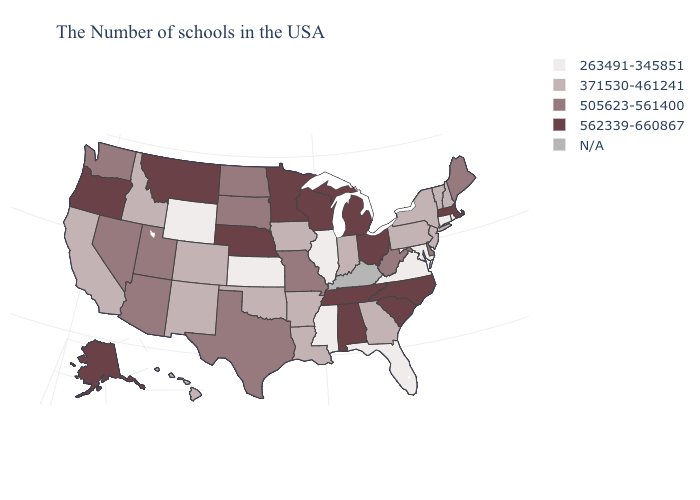Is the legend a continuous bar?
Write a very short answer. No. Among the states that border Delaware , which have the lowest value?
Write a very short answer. Maryland. What is the value of Oklahoma?
Concise answer only. 371530-461241. Name the states that have a value in the range 562339-660867?
Quick response, please. Massachusetts, North Carolina, South Carolina, Ohio, Michigan, Alabama, Tennessee, Wisconsin, Minnesota, Nebraska, Montana, Oregon, Alaska. What is the value of New York?
Keep it brief. 371530-461241. Does Nevada have the lowest value in the USA?
Keep it brief. No. Does Hawaii have the highest value in the West?
Quick response, please. No. Name the states that have a value in the range 562339-660867?
Quick response, please. Massachusetts, North Carolina, South Carolina, Ohio, Michigan, Alabama, Tennessee, Wisconsin, Minnesota, Nebraska, Montana, Oregon, Alaska. What is the lowest value in states that border Utah?
Quick response, please. 263491-345851. What is the highest value in states that border Texas?
Short answer required. 371530-461241. What is the value of Colorado?
Be succinct. 371530-461241. Among the states that border Oregon , which have the lowest value?
Keep it brief. Idaho, California. Which states have the highest value in the USA?
Quick response, please. Massachusetts, North Carolina, South Carolina, Ohio, Michigan, Alabama, Tennessee, Wisconsin, Minnesota, Nebraska, Montana, Oregon, Alaska. Among the states that border Colorado , which have the highest value?
Short answer required. Nebraska. 